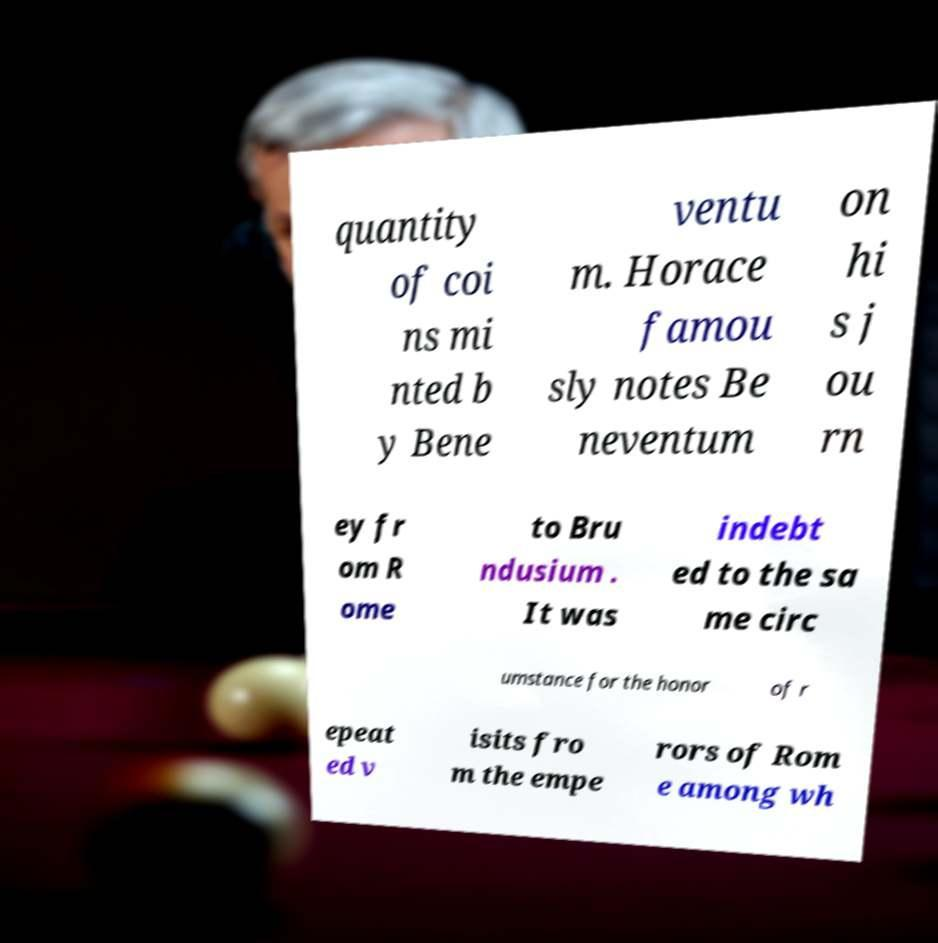There's text embedded in this image that I need extracted. Can you transcribe it verbatim? quantity of coi ns mi nted b y Bene ventu m. Horace famou sly notes Be neventum on hi s j ou rn ey fr om R ome to Bru ndusium . It was indebt ed to the sa me circ umstance for the honor of r epeat ed v isits fro m the empe rors of Rom e among wh 